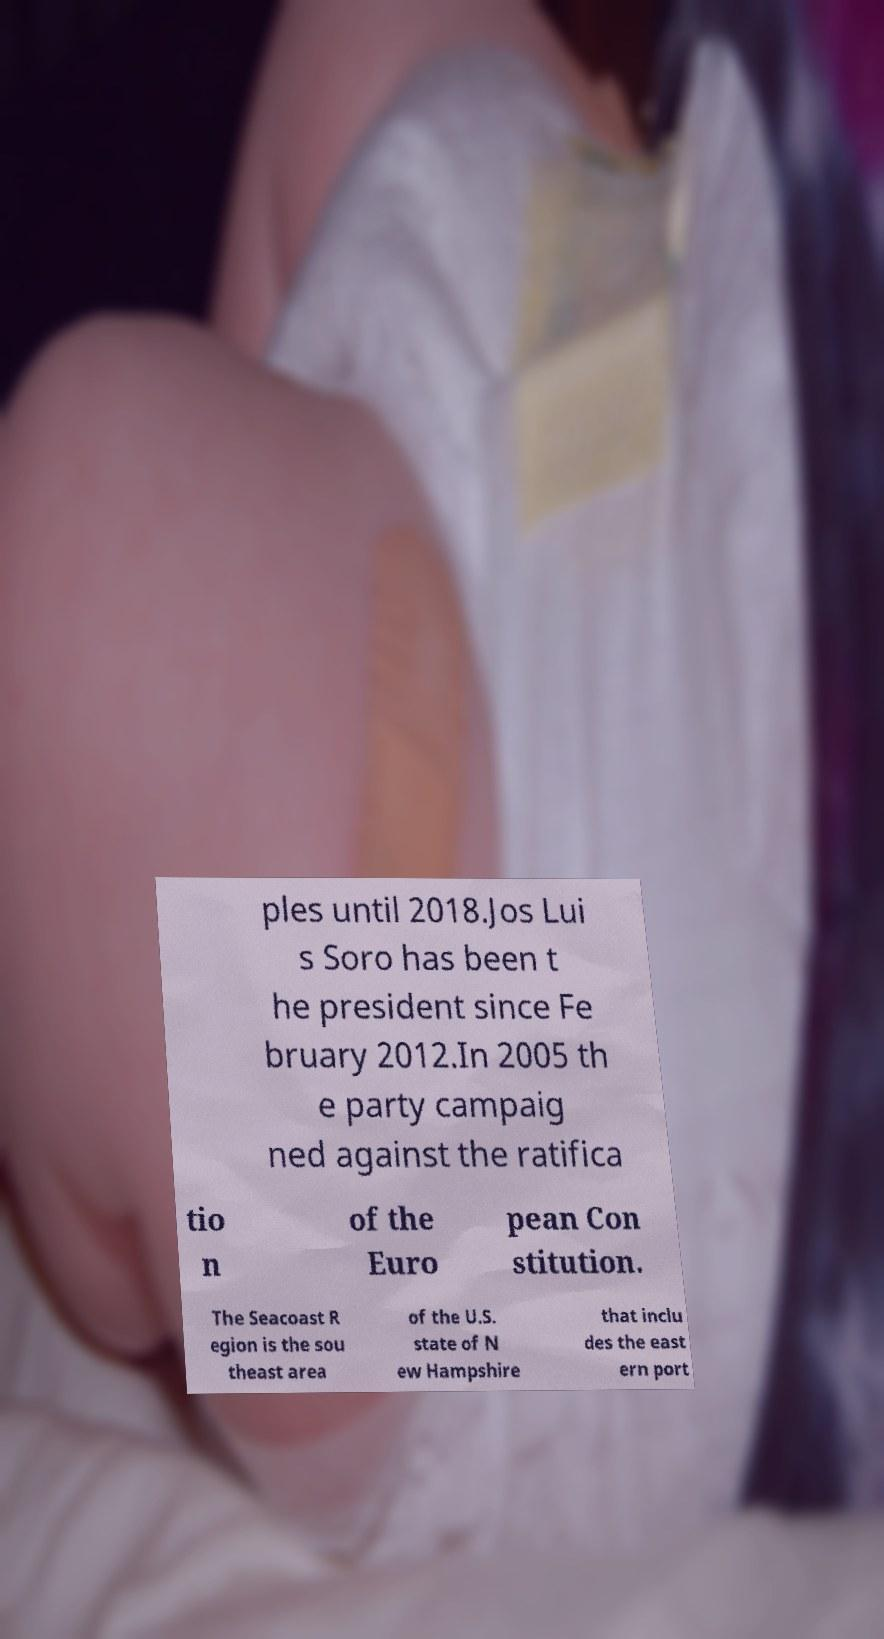Can you accurately transcribe the text from the provided image for me? ples until 2018.Jos Lui s Soro has been t he president since Fe bruary 2012.In 2005 th e party campaig ned against the ratifica tio n of the Euro pean Con stitution. The Seacoast R egion is the sou theast area of the U.S. state of N ew Hampshire that inclu des the east ern port 